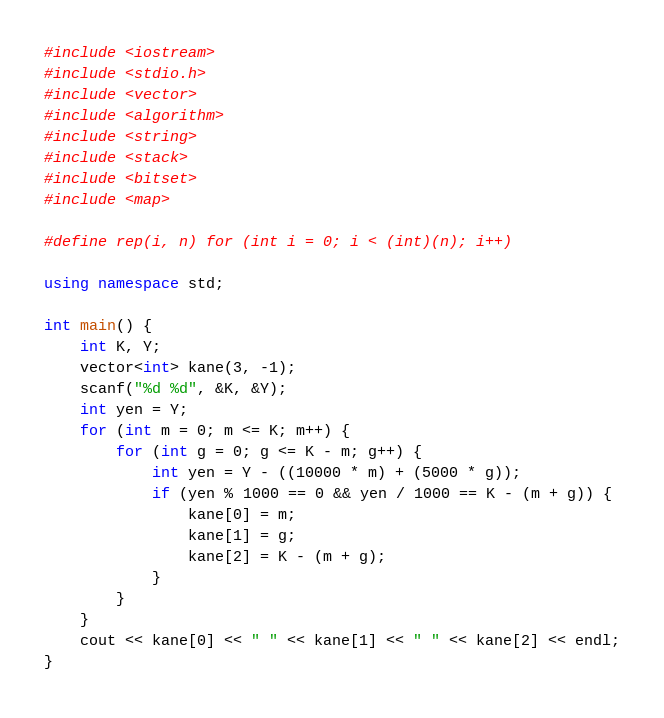Convert code to text. <code><loc_0><loc_0><loc_500><loc_500><_C++_>#include <iostream>
#include <stdio.h>
#include <vector>
#include <algorithm>
#include <string>
#include <stack>
#include <bitset>
#include <map>

#define rep(i, n) for (int i = 0; i < (int)(n); i++)

using namespace std;

int main() {
    int K, Y;
    vector<int> kane(3, -1);
    scanf("%d %d", &K, &Y);
    int yen = Y;
    for (int m = 0; m <= K; m++) {
        for (int g = 0; g <= K - m; g++) {
            int yen = Y - ((10000 * m) + (5000 * g));
            if (yen % 1000 == 0 && yen / 1000 == K - (m + g)) {
                kane[0] = m;
                kane[1] = g;
                kane[2] = K - (m + g);
            }
        }
    }
    cout << kane[0] << " " << kane[1] << " " << kane[2] << endl;
}</code> 